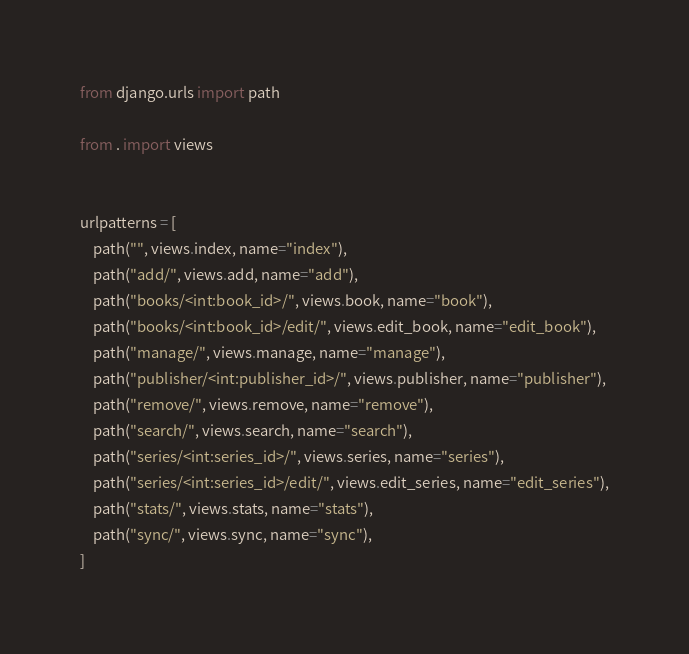<code> <loc_0><loc_0><loc_500><loc_500><_Python_>from django.urls import path

from . import views


urlpatterns = [
    path("", views.index, name="index"),
    path("add/", views.add, name="add"),
    path("books/<int:book_id>/", views.book, name="book"),
    path("books/<int:book_id>/edit/", views.edit_book, name="edit_book"),
    path("manage/", views.manage, name="manage"),
    path("publisher/<int:publisher_id>/", views.publisher, name="publisher"),
    path("remove/", views.remove, name="remove"),
    path("search/", views.search, name="search"),
    path("series/<int:series_id>/", views.series, name="series"),
    path("series/<int:series_id>/edit/", views.edit_series, name="edit_series"),
    path("stats/", views.stats, name="stats"),
    path("sync/", views.sync, name="sync"),
]
</code> 